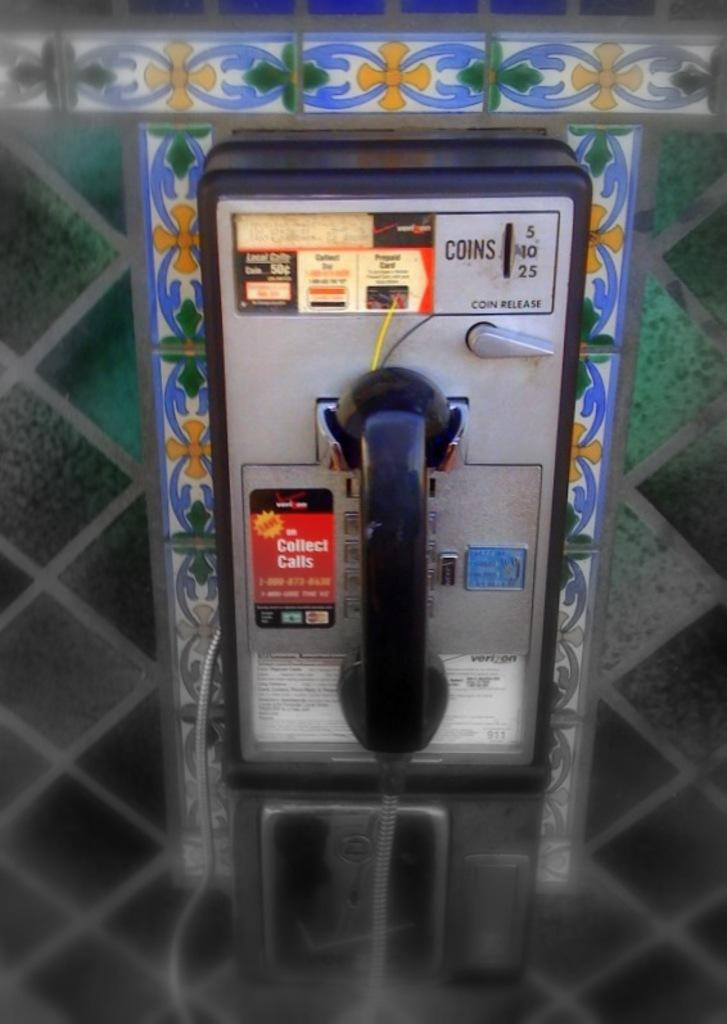<image>
Summarize the visual content of the image. A public telephone with the words Collect Calls to the left. 